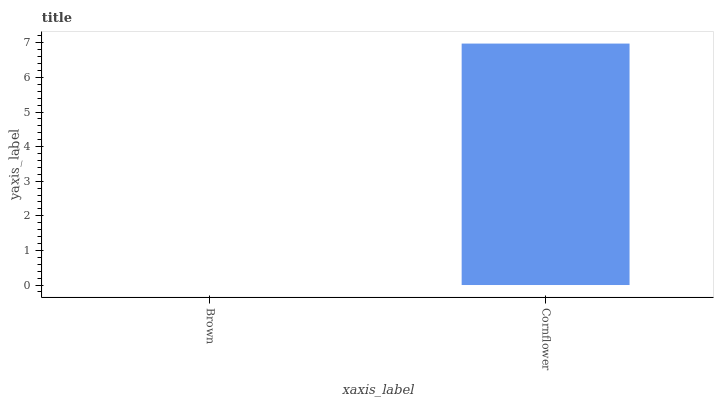Is Brown the minimum?
Answer yes or no. Yes. Is Cornflower the maximum?
Answer yes or no. Yes. Is Cornflower the minimum?
Answer yes or no. No. Is Cornflower greater than Brown?
Answer yes or no. Yes. Is Brown less than Cornflower?
Answer yes or no. Yes. Is Brown greater than Cornflower?
Answer yes or no. No. Is Cornflower less than Brown?
Answer yes or no. No. Is Cornflower the high median?
Answer yes or no. Yes. Is Brown the low median?
Answer yes or no. Yes. Is Brown the high median?
Answer yes or no. No. Is Cornflower the low median?
Answer yes or no. No. 